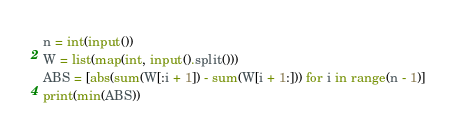<code> <loc_0><loc_0><loc_500><loc_500><_Python_>n = int(input())
W = list(map(int, input().split()))
ABS = [abs(sum(W[:i + 1]) - sum(W[i + 1:])) for i in range(n - 1)]
print(min(ABS))</code> 